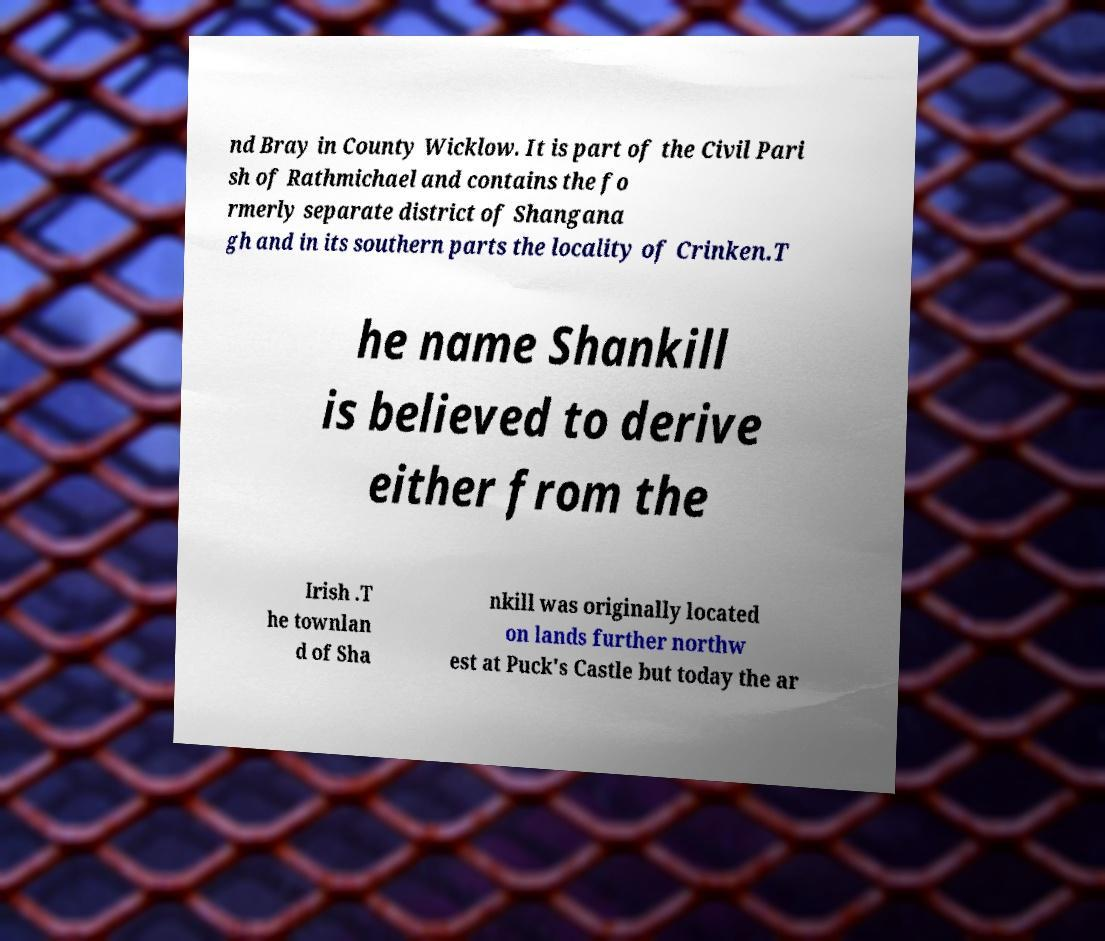Could you assist in decoding the text presented in this image and type it out clearly? nd Bray in County Wicklow. It is part of the Civil Pari sh of Rathmichael and contains the fo rmerly separate district of Shangana gh and in its southern parts the locality of Crinken.T he name Shankill is believed to derive either from the Irish .T he townlan d of Sha nkill was originally located on lands further northw est at Puck's Castle but today the ar 